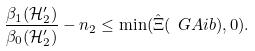Convert formula to latex. <formula><loc_0><loc_0><loc_500><loc_500>\frac { \beta _ { 1 } ( { \mathcal { H } } ^ { \prime } _ { 2 } ) } { \beta _ { 0 } ( { \mathcal { H } } ^ { \prime } _ { 2 } ) } - n _ { 2 } \leq \min ( \hat { \Xi } ( \ G A i b ) , 0 ) .</formula> 